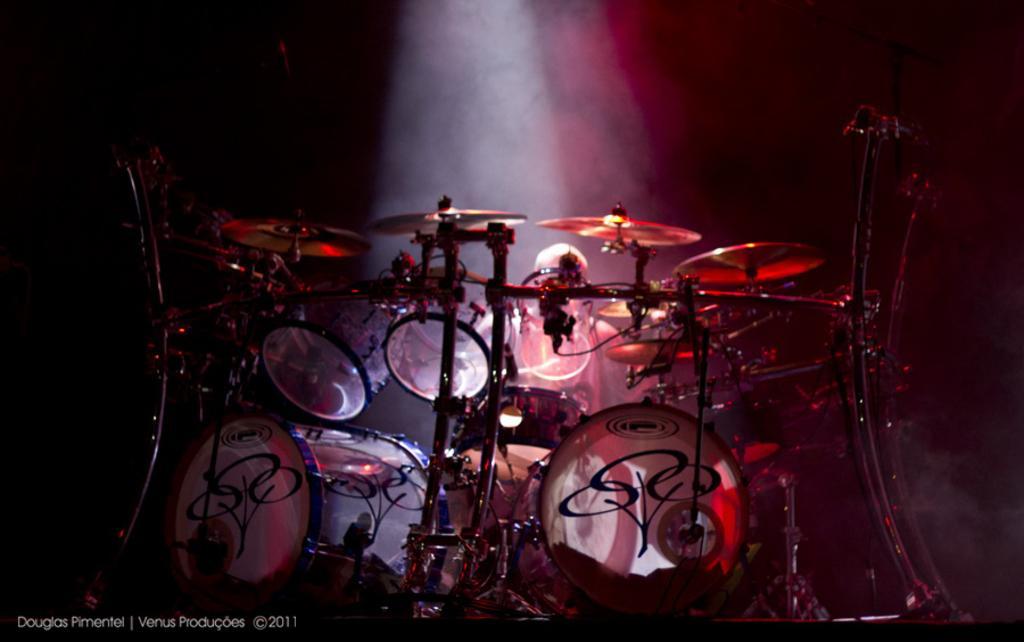How would you summarize this image in a sentence or two? In the picture I can see electronic drums and a person sitting there. The background of the image is dark and here I can see the lights. Here I can see the watermark on the bottom left side of the image. 